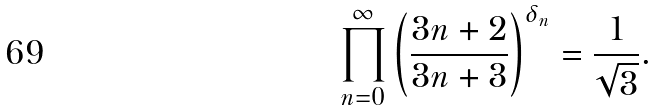<formula> <loc_0><loc_0><loc_500><loc_500>\prod _ { n = 0 } ^ { \infty } \left ( \frac { 3 n + 2 } { 3 n + 3 } \right ) ^ { \delta _ { n } } = \frac { 1 } { \sqrt { 3 } } .</formula> 